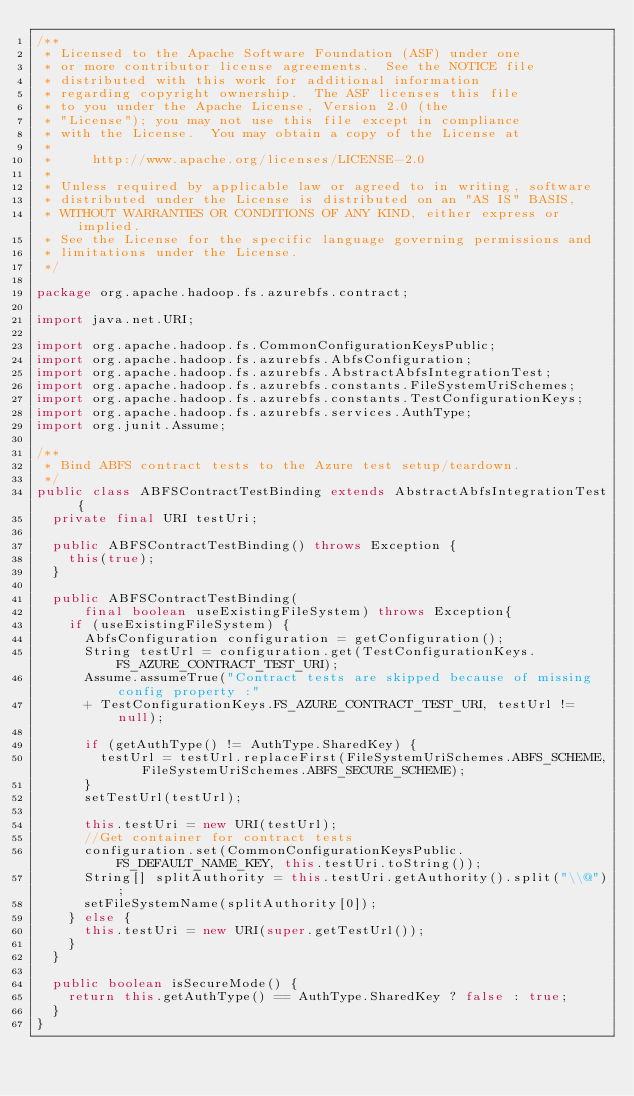Convert code to text. <code><loc_0><loc_0><loc_500><loc_500><_Java_>/**
 * Licensed to the Apache Software Foundation (ASF) under one
 * or more contributor license agreements.  See the NOTICE file
 * distributed with this work for additional information
 * regarding copyright ownership.  The ASF licenses this file
 * to you under the Apache License, Version 2.0 (the
 * "License"); you may not use this file except in compliance
 * with the License.  You may obtain a copy of the License at
 *
 *     http://www.apache.org/licenses/LICENSE-2.0
 *
 * Unless required by applicable law or agreed to in writing, software
 * distributed under the License is distributed on an "AS IS" BASIS,
 * WITHOUT WARRANTIES OR CONDITIONS OF ANY KIND, either express or implied.
 * See the License for the specific language governing permissions and
 * limitations under the License.
 */

package org.apache.hadoop.fs.azurebfs.contract;

import java.net.URI;

import org.apache.hadoop.fs.CommonConfigurationKeysPublic;
import org.apache.hadoop.fs.azurebfs.AbfsConfiguration;
import org.apache.hadoop.fs.azurebfs.AbstractAbfsIntegrationTest;
import org.apache.hadoop.fs.azurebfs.constants.FileSystemUriSchemes;
import org.apache.hadoop.fs.azurebfs.constants.TestConfigurationKeys;
import org.apache.hadoop.fs.azurebfs.services.AuthType;
import org.junit.Assume;

/**
 * Bind ABFS contract tests to the Azure test setup/teardown.
 */
public class ABFSContractTestBinding extends AbstractAbfsIntegrationTest {
  private final URI testUri;

  public ABFSContractTestBinding() throws Exception {
    this(true);
  }

  public ABFSContractTestBinding(
      final boolean useExistingFileSystem) throws Exception{
    if (useExistingFileSystem) {
      AbfsConfiguration configuration = getConfiguration();
      String testUrl = configuration.get(TestConfigurationKeys.FS_AZURE_CONTRACT_TEST_URI);
      Assume.assumeTrue("Contract tests are skipped because of missing config property :"
      + TestConfigurationKeys.FS_AZURE_CONTRACT_TEST_URI, testUrl != null);

      if (getAuthType() != AuthType.SharedKey) {
        testUrl = testUrl.replaceFirst(FileSystemUriSchemes.ABFS_SCHEME, FileSystemUriSchemes.ABFS_SECURE_SCHEME);
      }
      setTestUrl(testUrl);

      this.testUri = new URI(testUrl);
      //Get container for contract tests
      configuration.set(CommonConfigurationKeysPublic.FS_DEFAULT_NAME_KEY, this.testUri.toString());
      String[] splitAuthority = this.testUri.getAuthority().split("\\@");
      setFileSystemName(splitAuthority[0]);
    } else {
      this.testUri = new URI(super.getTestUrl());
    }
  }

  public boolean isSecureMode() {
    return this.getAuthType() == AuthType.SharedKey ? false : true;
  }
}
</code> 